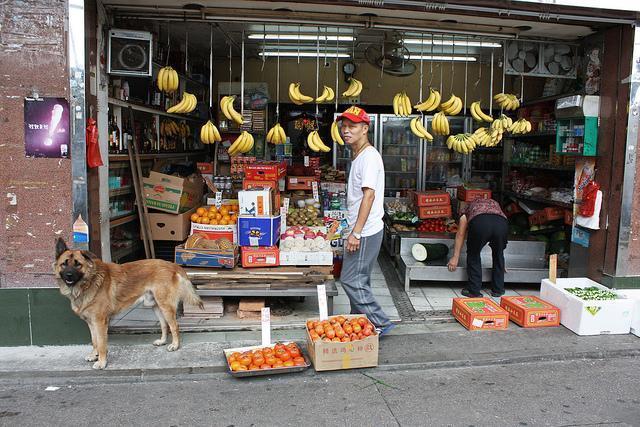How many boxes of tomatoes are on the street?
Give a very brief answer. 2. How many people can you see?
Give a very brief answer. 2. How many toilets are there?
Give a very brief answer. 0. 